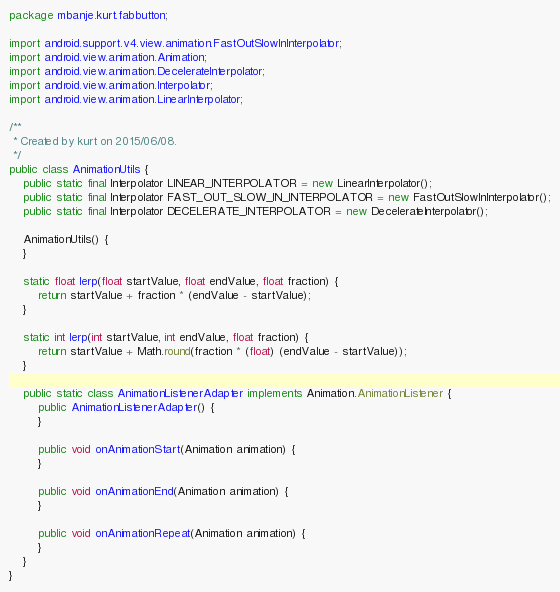Convert code to text. <code><loc_0><loc_0><loc_500><loc_500><_Java_>package mbanje.kurt.fabbutton;

import android.support.v4.view.animation.FastOutSlowInInterpolator;
import android.view.animation.Animation;
import android.view.animation.DecelerateInterpolator;
import android.view.animation.Interpolator;
import android.view.animation.LinearInterpolator;

/**
 * Created by kurt on 2015/06/08.
 */
public class AnimationUtils {
    public static final Interpolator LINEAR_INTERPOLATOR = new LinearInterpolator();
    public static final Interpolator FAST_OUT_SLOW_IN_INTERPOLATOR = new FastOutSlowInInterpolator();
    public static final Interpolator DECELERATE_INTERPOLATOR = new DecelerateInterpolator();

    AnimationUtils() {
    }

    static float lerp(float startValue, float endValue, float fraction) {
        return startValue + fraction * (endValue - startValue);
    }

    static int lerp(int startValue, int endValue, float fraction) {
        return startValue + Math.round(fraction * (float) (endValue - startValue));
    }

    public static class AnimationListenerAdapter implements Animation.AnimationListener {
        public AnimationListenerAdapter() {
        }

        public void onAnimationStart(Animation animation) {
        }

        public void onAnimationEnd(Animation animation) {
        }

        public void onAnimationRepeat(Animation animation) {
        }
    }
}

</code> 